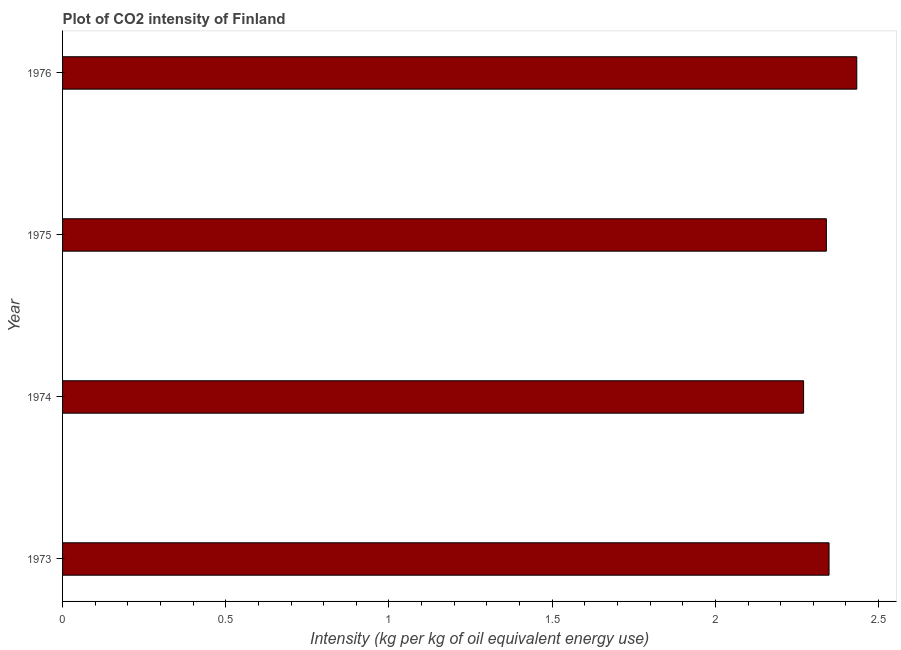Does the graph contain any zero values?
Your answer should be very brief. No. What is the title of the graph?
Your response must be concise. Plot of CO2 intensity of Finland. What is the label or title of the X-axis?
Give a very brief answer. Intensity (kg per kg of oil equivalent energy use). What is the label or title of the Y-axis?
Your response must be concise. Year. What is the co2 intensity in 1974?
Provide a succinct answer. 2.27. Across all years, what is the maximum co2 intensity?
Provide a succinct answer. 2.43. Across all years, what is the minimum co2 intensity?
Keep it short and to the point. 2.27. In which year was the co2 intensity maximum?
Offer a terse response. 1976. In which year was the co2 intensity minimum?
Your answer should be very brief. 1974. What is the sum of the co2 intensity?
Make the answer very short. 9.39. What is the difference between the co2 intensity in 1975 and 1976?
Offer a terse response. -0.09. What is the average co2 intensity per year?
Your answer should be compact. 2.35. What is the median co2 intensity?
Provide a short and direct response. 2.34. In how many years, is the co2 intensity greater than 1.8 kg?
Keep it short and to the point. 4. What is the ratio of the co2 intensity in 1973 to that in 1974?
Ensure brevity in your answer.  1.03. Is the co2 intensity in 1975 less than that in 1976?
Give a very brief answer. Yes. Is the difference between the co2 intensity in 1975 and 1976 greater than the difference between any two years?
Your answer should be compact. No. What is the difference between the highest and the second highest co2 intensity?
Your response must be concise. 0.09. What is the difference between the highest and the lowest co2 intensity?
Offer a very short reply. 0.16. In how many years, is the co2 intensity greater than the average co2 intensity taken over all years?
Your answer should be compact. 2. Are all the bars in the graph horizontal?
Ensure brevity in your answer.  Yes. How many years are there in the graph?
Your answer should be compact. 4. What is the difference between two consecutive major ticks on the X-axis?
Make the answer very short. 0.5. What is the Intensity (kg per kg of oil equivalent energy use) of 1973?
Provide a succinct answer. 2.35. What is the Intensity (kg per kg of oil equivalent energy use) in 1974?
Your answer should be compact. 2.27. What is the Intensity (kg per kg of oil equivalent energy use) of 1975?
Give a very brief answer. 2.34. What is the Intensity (kg per kg of oil equivalent energy use) in 1976?
Your answer should be compact. 2.43. What is the difference between the Intensity (kg per kg of oil equivalent energy use) in 1973 and 1974?
Your response must be concise. 0.08. What is the difference between the Intensity (kg per kg of oil equivalent energy use) in 1973 and 1975?
Provide a succinct answer. 0.01. What is the difference between the Intensity (kg per kg of oil equivalent energy use) in 1973 and 1976?
Keep it short and to the point. -0.08. What is the difference between the Intensity (kg per kg of oil equivalent energy use) in 1974 and 1975?
Ensure brevity in your answer.  -0.07. What is the difference between the Intensity (kg per kg of oil equivalent energy use) in 1974 and 1976?
Make the answer very short. -0.16. What is the difference between the Intensity (kg per kg of oil equivalent energy use) in 1975 and 1976?
Provide a succinct answer. -0.09. What is the ratio of the Intensity (kg per kg of oil equivalent energy use) in 1973 to that in 1974?
Your answer should be very brief. 1.03. What is the ratio of the Intensity (kg per kg of oil equivalent energy use) in 1973 to that in 1976?
Offer a terse response. 0.96. What is the ratio of the Intensity (kg per kg of oil equivalent energy use) in 1974 to that in 1976?
Your answer should be very brief. 0.93. What is the ratio of the Intensity (kg per kg of oil equivalent energy use) in 1975 to that in 1976?
Your response must be concise. 0.96. 